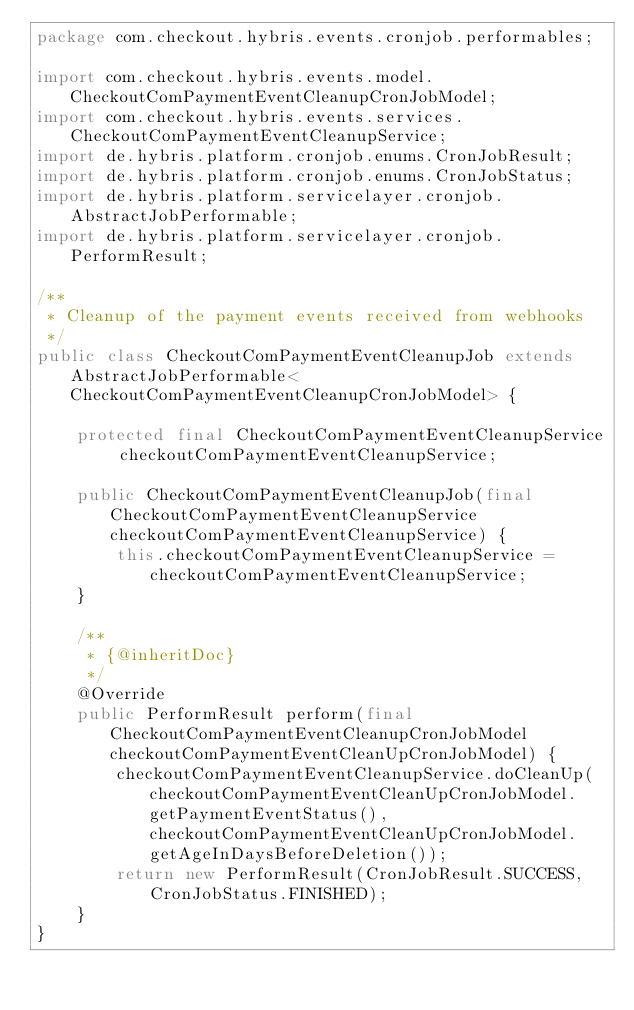Convert code to text. <code><loc_0><loc_0><loc_500><loc_500><_Java_>package com.checkout.hybris.events.cronjob.performables;

import com.checkout.hybris.events.model.CheckoutComPaymentEventCleanupCronJobModel;
import com.checkout.hybris.events.services.CheckoutComPaymentEventCleanupService;
import de.hybris.platform.cronjob.enums.CronJobResult;
import de.hybris.platform.cronjob.enums.CronJobStatus;
import de.hybris.platform.servicelayer.cronjob.AbstractJobPerformable;
import de.hybris.platform.servicelayer.cronjob.PerformResult;

/**
 * Cleanup of the payment events received from webhooks
 */
public class CheckoutComPaymentEventCleanupJob extends AbstractJobPerformable<CheckoutComPaymentEventCleanupCronJobModel> {

    protected final CheckoutComPaymentEventCleanupService checkoutComPaymentEventCleanupService;

    public CheckoutComPaymentEventCleanupJob(final CheckoutComPaymentEventCleanupService checkoutComPaymentEventCleanupService) {
        this.checkoutComPaymentEventCleanupService = checkoutComPaymentEventCleanupService;
    }

    /**
     * {@inheritDoc}
     */
    @Override
    public PerformResult perform(final CheckoutComPaymentEventCleanupCronJobModel checkoutComPaymentEventCleanUpCronJobModel) {
        checkoutComPaymentEventCleanupService.doCleanUp(checkoutComPaymentEventCleanUpCronJobModel.getPaymentEventStatus(), checkoutComPaymentEventCleanUpCronJobModel.getAgeInDaysBeforeDeletion());
        return new PerformResult(CronJobResult.SUCCESS, CronJobStatus.FINISHED);
    }
}</code> 